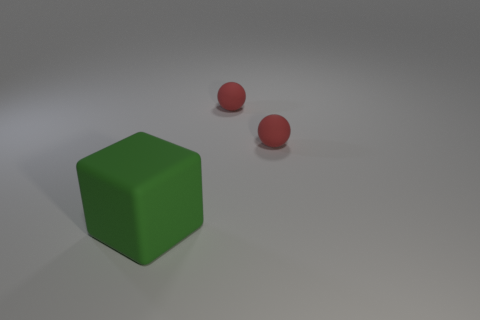What number of small red balls have the same material as the green object? There are two small red balls shown in the image that appear to have a shiny, smooth surface which is similar to the material of the sizable green cube. 